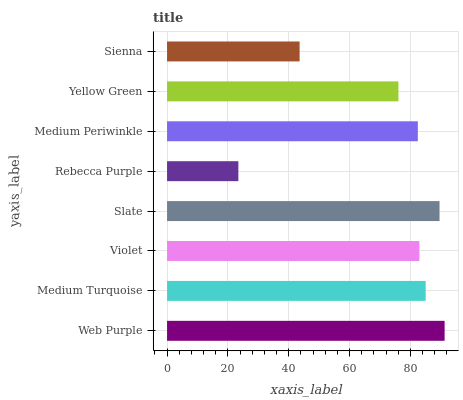Is Rebecca Purple the minimum?
Answer yes or no. Yes. Is Web Purple the maximum?
Answer yes or no. Yes. Is Medium Turquoise the minimum?
Answer yes or no. No. Is Medium Turquoise the maximum?
Answer yes or no. No. Is Web Purple greater than Medium Turquoise?
Answer yes or no. Yes. Is Medium Turquoise less than Web Purple?
Answer yes or no. Yes. Is Medium Turquoise greater than Web Purple?
Answer yes or no. No. Is Web Purple less than Medium Turquoise?
Answer yes or no. No. Is Violet the high median?
Answer yes or no. Yes. Is Medium Periwinkle the low median?
Answer yes or no. Yes. Is Rebecca Purple the high median?
Answer yes or no. No. Is Web Purple the low median?
Answer yes or no. No. 